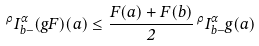Convert formula to latex. <formula><loc_0><loc_0><loc_500><loc_500>\, ^ { \rho } I ^ { \alpha } _ { b - } ( g F ) ( a ) \leq \frac { F ( a ) + F ( b ) } { 2 } \, ^ { \rho } I ^ { \alpha } _ { b - } g ( a )</formula> 